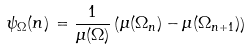<formula> <loc_0><loc_0><loc_500><loc_500>\psi _ { \Omega } ( n ) \, = \frac { 1 } { \mu ( \Omega ) } \left ( \mu ( \Omega _ { n } ) - \mu ( \Omega _ { n + 1 } ) \right )</formula> 